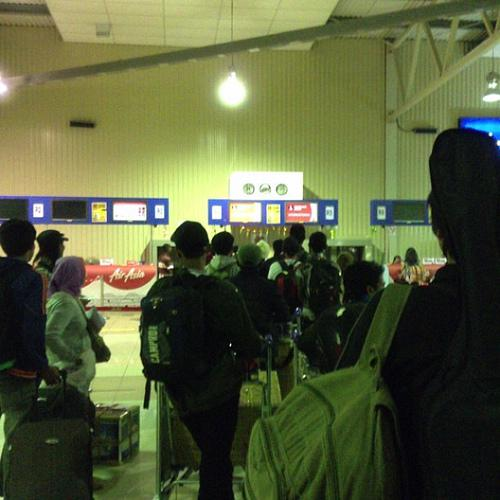Question: where are the people?
Choices:
A. In line.
B. Outside.
C. Living room.
D. Kitchen.
Answer with the letter. Answer: A Question: what is hanging from the ceiling?
Choices:
A. Fan.
B. Chandelier.
C. Decorations.
D. Lights.
Answer with the letter. Answer: D Question: how many blue signs can be seen?
Choices:
A. 4.
B. 3.
C. 5.
D. 6.
Answer with the letter. Answer: B Question: what color are the walls?
Choices:
A. White.
B. Beige.
C. Green.
D. Yellow.
Answer with the letter. Answer: B Question: who is in the picture?
Choices:
A. Children.
B. Men.
C. Travelers.
D. Women.
Answer with the letter. Answer: C Question: what airline name is seen?
Choices:
A. Virgin.
B. American Airlines.
C. Air Asia.
D. Delta.
Answer with the letter. Answer: C 